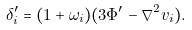<formula> <loc_0><loc_0><loc_500><loc_500>\delta _ { i } ^ { \prime } = ( 1 + \omega _ { i } ) ( 3 \Phi ^ { \prime } - \nabla ^ { 2 } v _ { i } ) .</formula> 